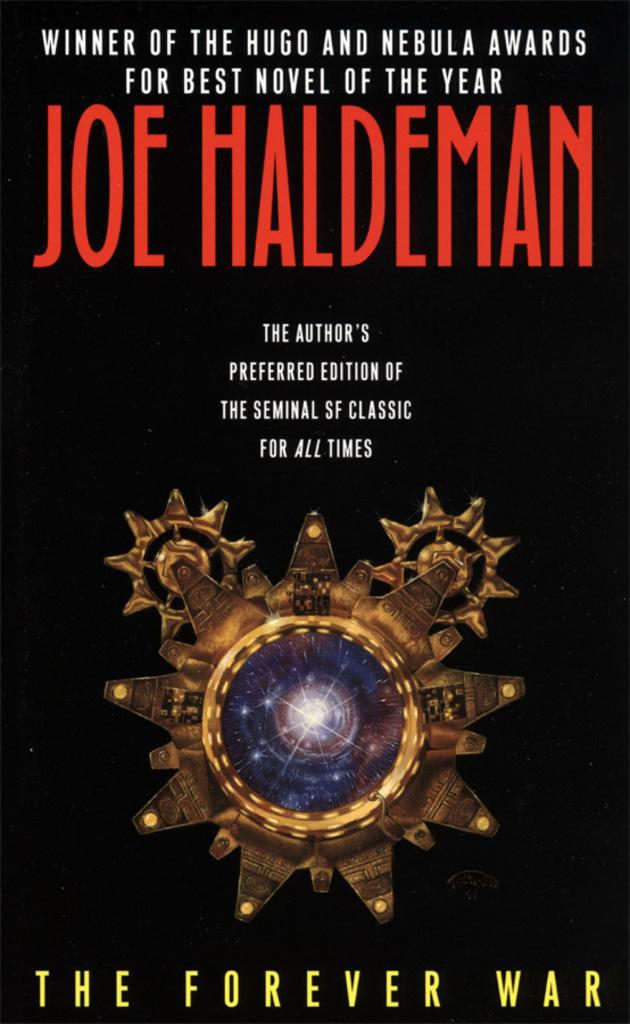<image>
Provide a brief description of the given image. The Forever War has a golden star with a constellation like blue center on it. 